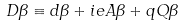Convert formula to latex. <formula><loc_0><loc_0><loc_500><loc_500>D \beta \equiv d \beta + i e A \beta + q Q \beta</formula> 